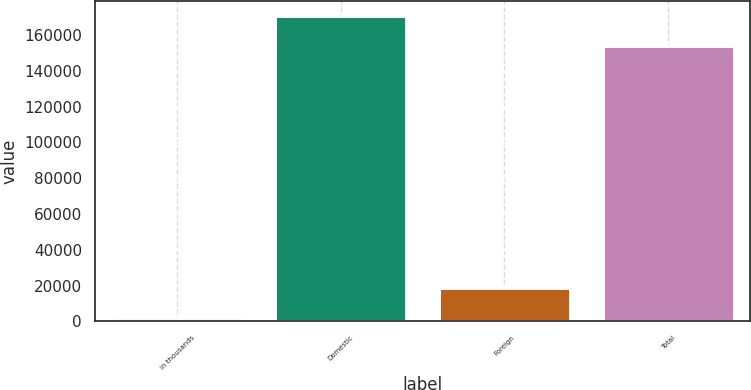Convert chart to OTSL. <chart><loc_0><loc_0><loc_500><loc_500><bar_chart><fcel>in thousands<fcel>Domestic<fcel>Foreign<fcel>Total<nl><fcel>2011<fcel>170513<fcel>18785.7<fcel>153738<nl></chart> 